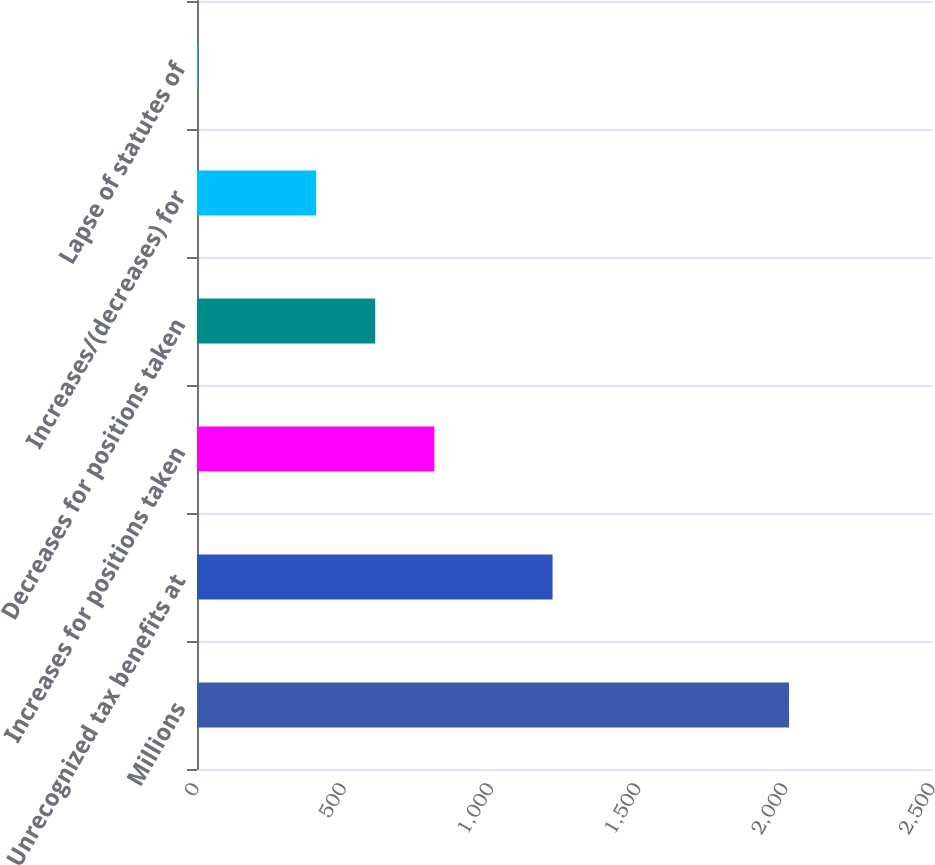<chart> <loc_0><loc_0><loc_500><loc_500><bar_chart><fcel>Millions<fcel>Unrecognized tax benefits at<fcel>Increases for positions taken<fcel>Decreases for positions taken<fcel>Increases/(decreases) for<fcel>Lapse of statutes of<nl><fcel>2011<fcel>1207.8<fcel>806.2<fcel>605.4<fcel>404.6<fcel>3<nl></chart> 